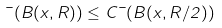Convert formula to latex. <formula><loc_0><loc_0><loc_500><loc_500>\mu ( B ( x , R ) ) \leq C \mu ( B ( x , R / 2 ) )</formula> 